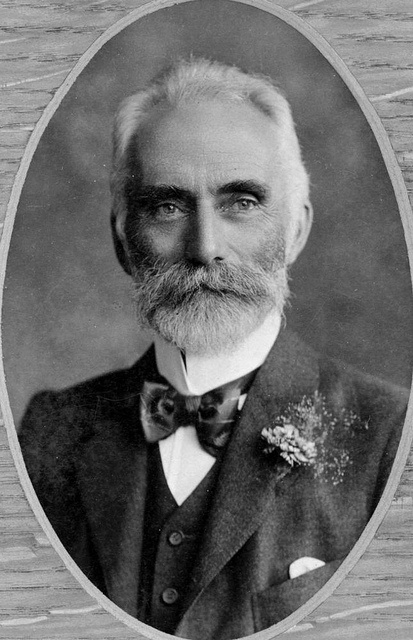Describe the objects in this image and their specific colors. I can see people in darkgray, black, gray, and lightgray tones and tie in darkgray, black, gray, and lightgray tones in this image. 